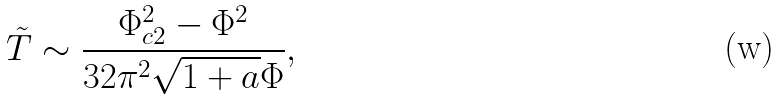<formula> <loc_0><loc_0><loc_500><loc_500>\tilde { T } \sim \frac { \Phi _ { c 2 } ^ { 2 } - \Phi ^ { 2 } } { 3 2 \pi ^ { 2 } \sqrt { 1 + a } \Phi } ,</formula> 